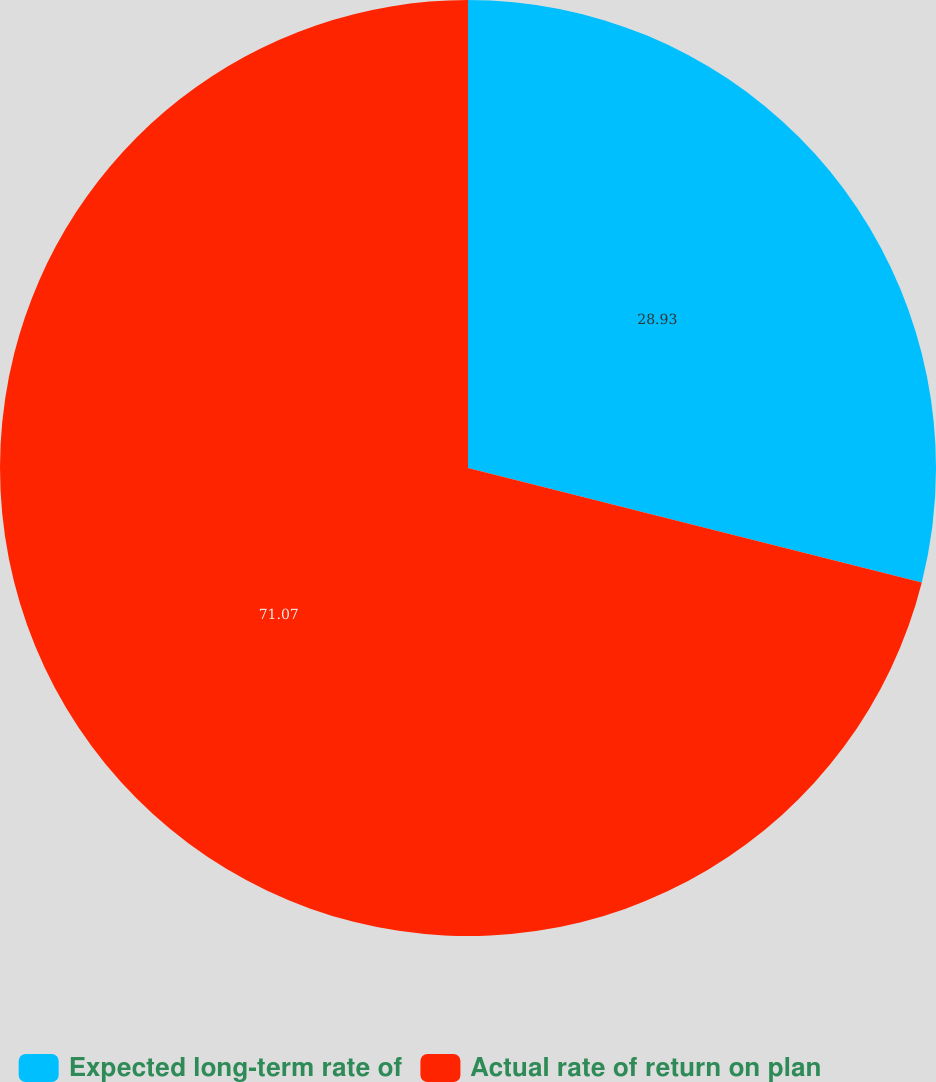Convert chart to OTSL. <chart><loc_0><loc_0><loc_500><loc_500><pie_chart><fcel>Expected long-term rate of<fcel>Actual rate of return on plan<nl><fcel>28.93%<fcel>71.07%<nl></chart> 